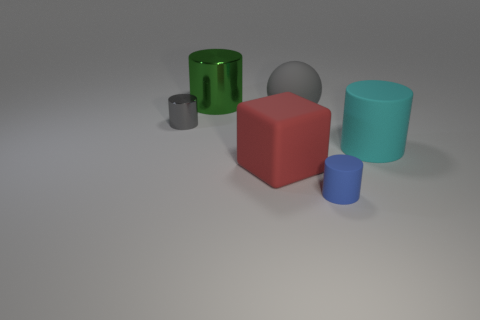Add 1 large things. How many objects exist? 7 Subtract all cylinders. How many objects are left? 2 Subtract all gray things. Subtract all spheres. How many objects are left? 3 Add 5 blue rubber cylinders. How many blue rubber cylinders are left? 6 Add 6 big gray things. How many big gray things exist? 7 Subtract 0 yellow cylinders. How many objects are left? 6 